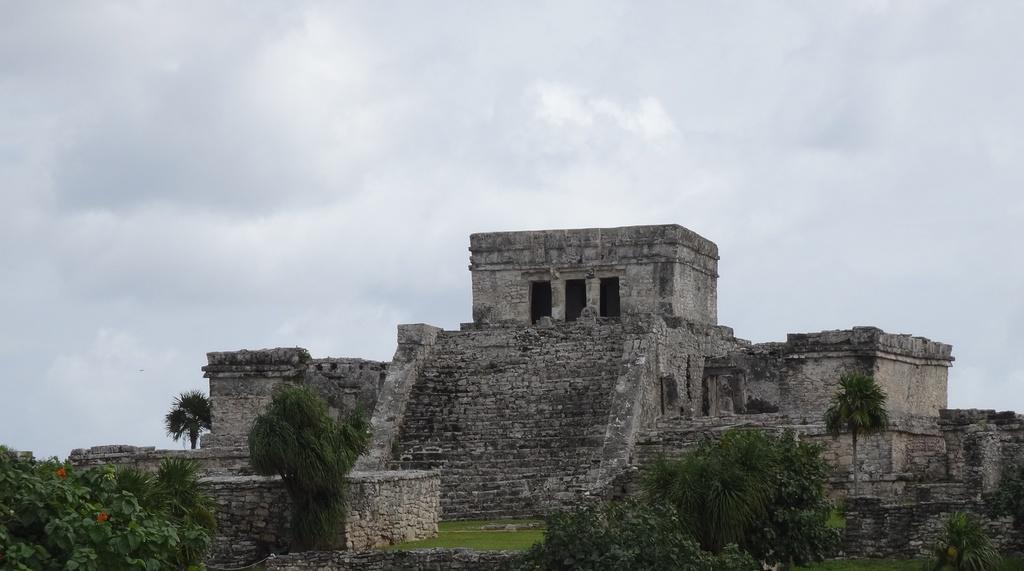What can be seen in the foreground of the image? There are trees and a monument building in the foreground of the image. What is visible at the top of the image? The sky is visible at the top of the image. What statement does the woman make in the image? There is no woman present in the image, so no statement can be attributed to her. Can you see a hose in the image? There is no hose present in the image. 